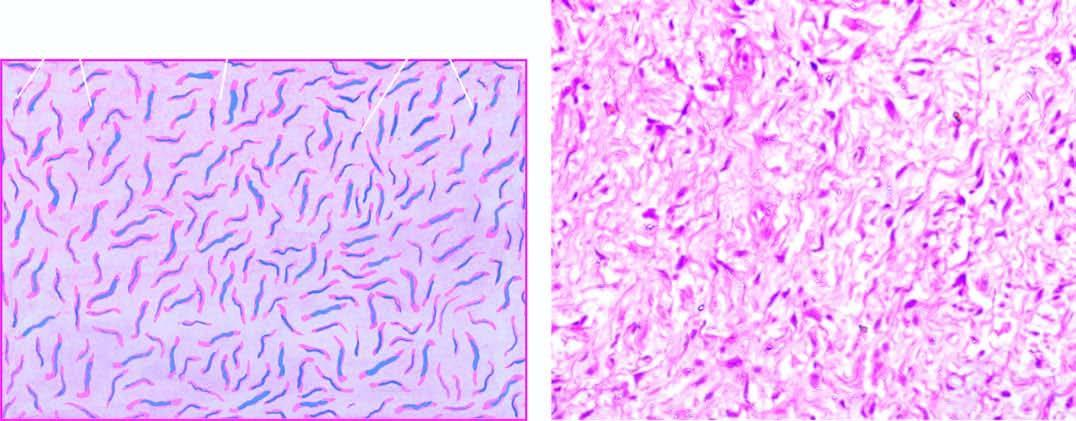do the cells have wavy nuclei?
Answer the question using a single word or phrase. Yes 